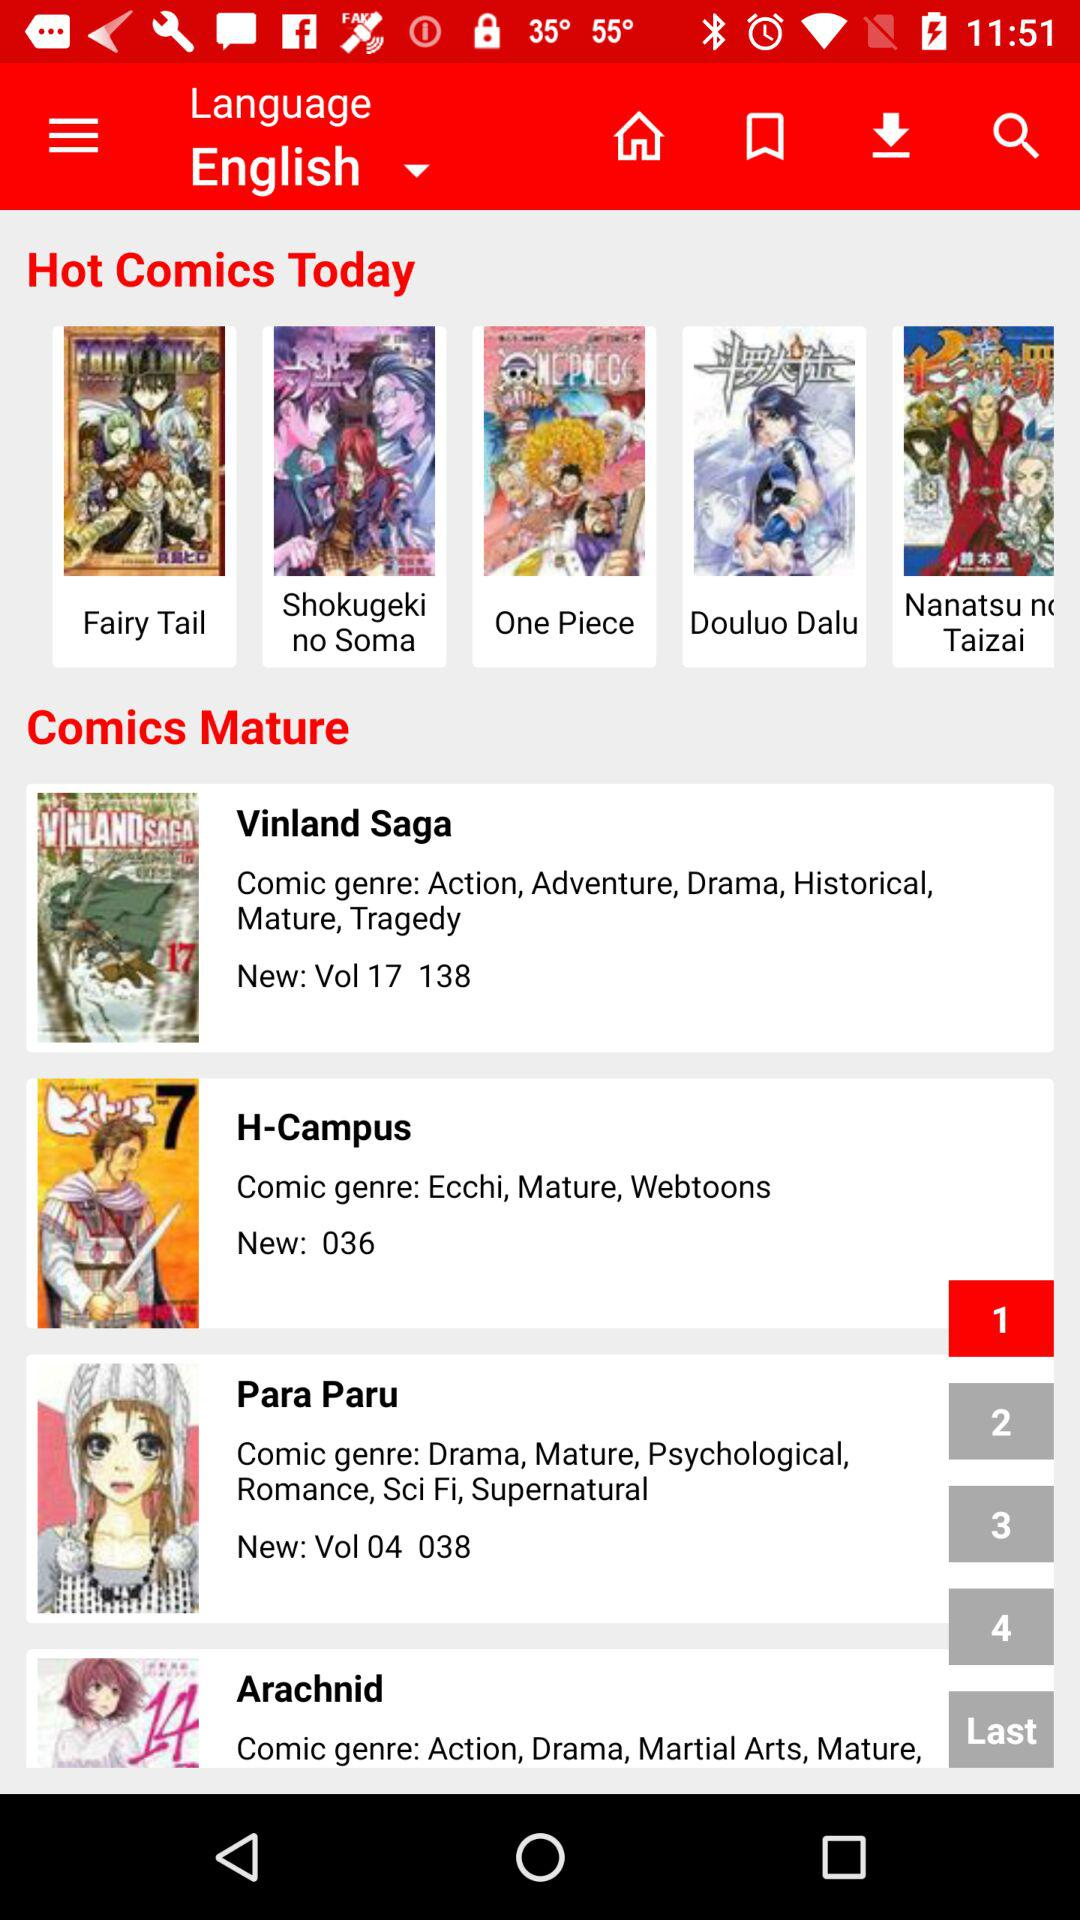How many editors worked on this manga?
Answer the question using a single word or phrase. 3 